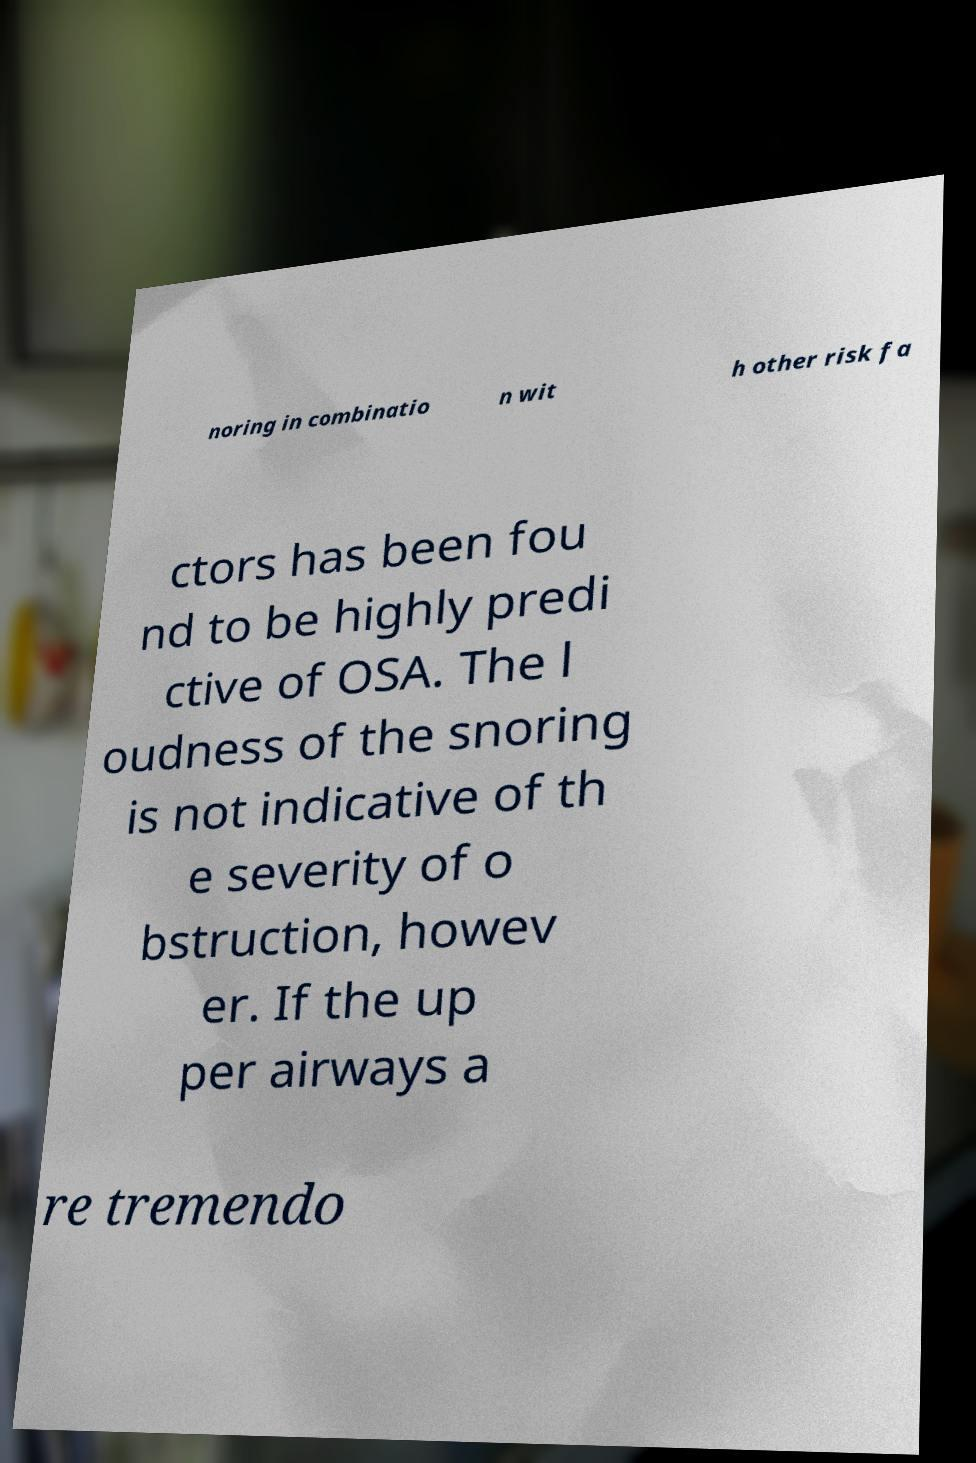Can you accurately transcribe the text from the provided image for me? noring in combinatio n wit h other risk fa ctors has been fou nd to be highly predi ctive of OSA. The l oudness of the snoring is not indicative of th e severity of o bstruction, howev er. If the up per airways a re tremendo 